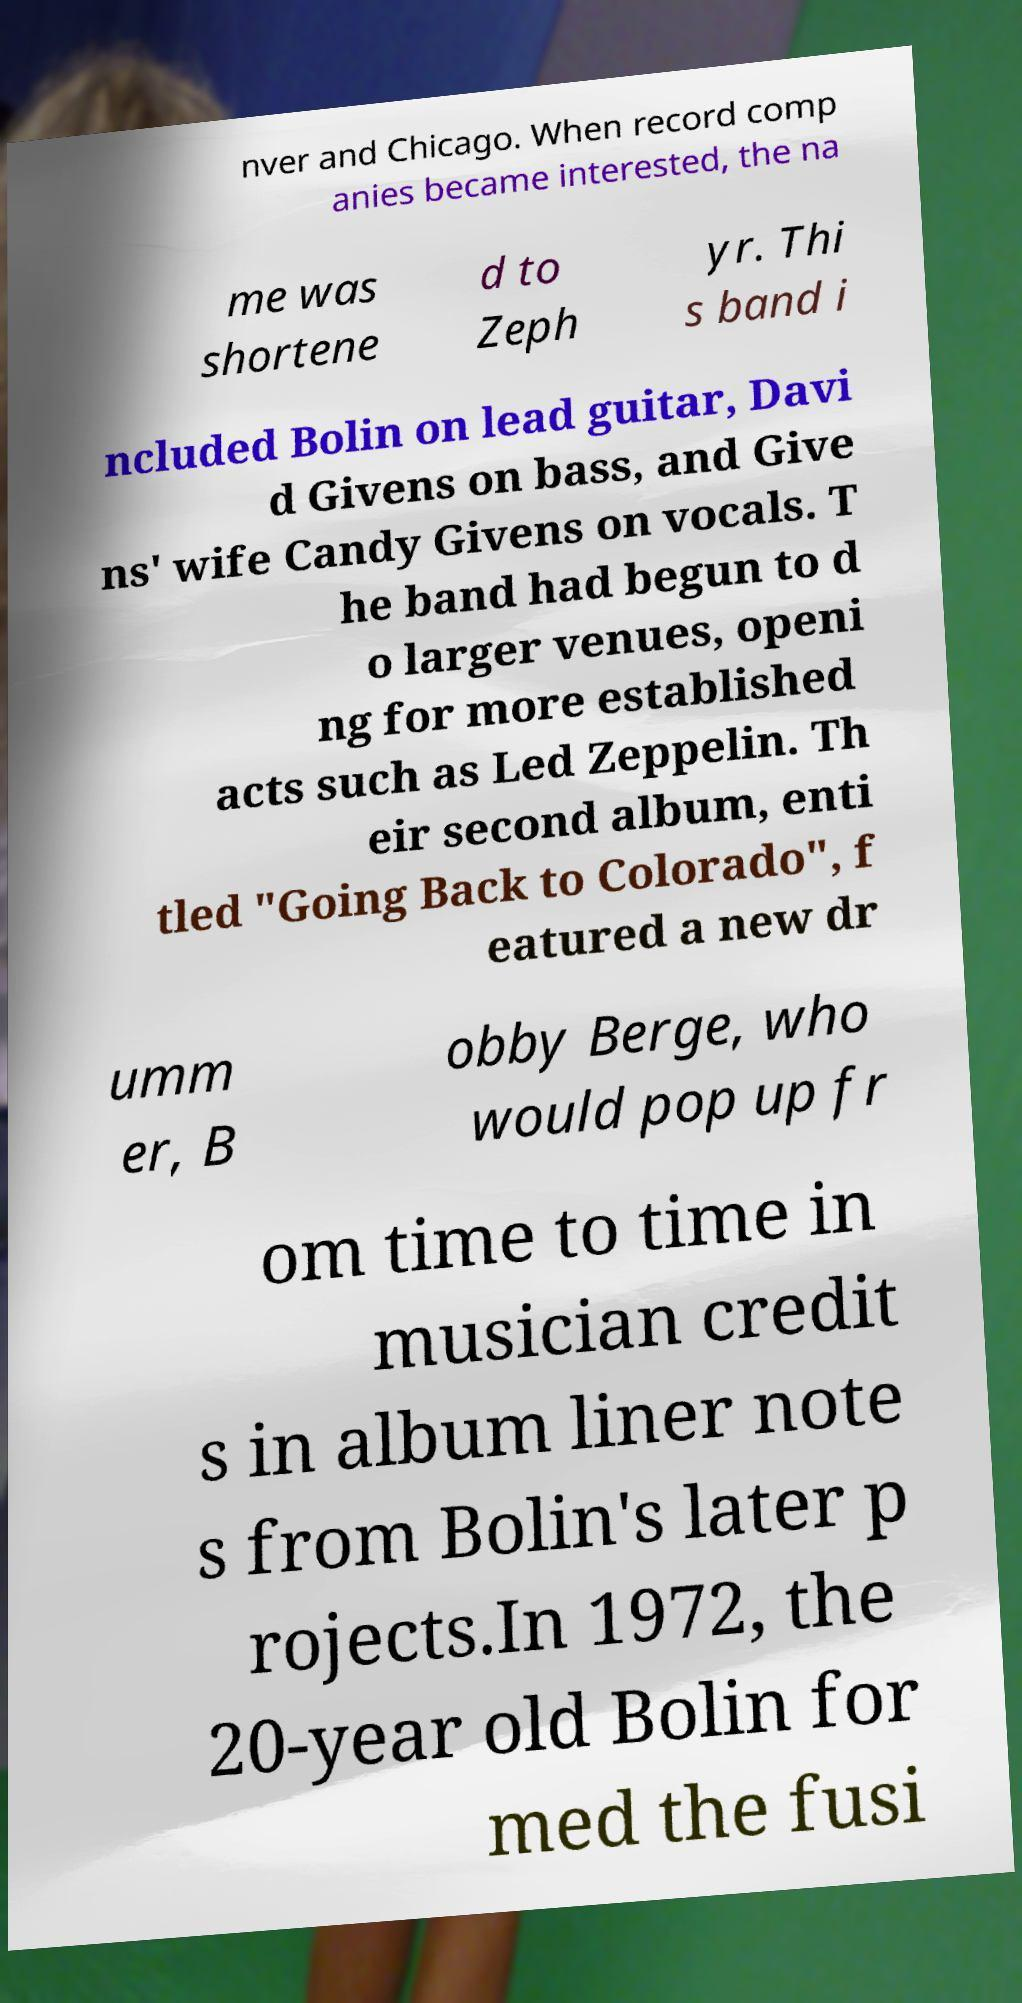I need the written content from this picture converted into text. Can you do that? nver and Chicago. When record comp anies became interested, the na me was shortene d to Zeph yr. Thi s band i ncluded Bolin on lead guitar, Davi d Givens on bass, and Give ns' wife Candy Givens on vocals. T he band had begun to d o larger venues, openi ng for more established acts such as Led Zeppelin. Th eir second album, enti tled "Going Back to Colorado", f eatured a new dr umm er, B obby Berge, who would pop up fr om time to time in musician credit s in album liner note s from Bolin's later p rojects.In 1972, the 20-year old Bolin for med the fusi 